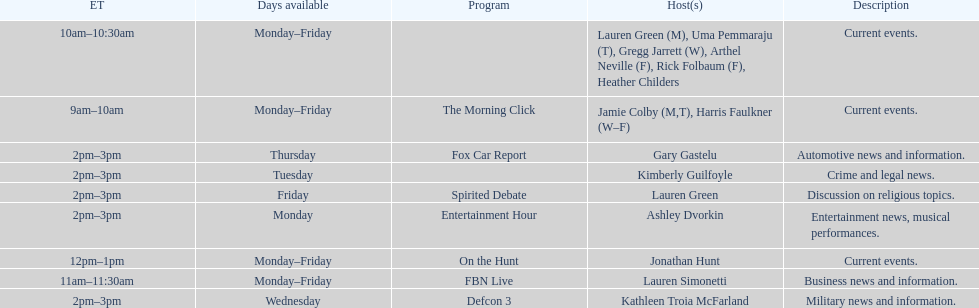How long does on the hunt run? 1 hour. 